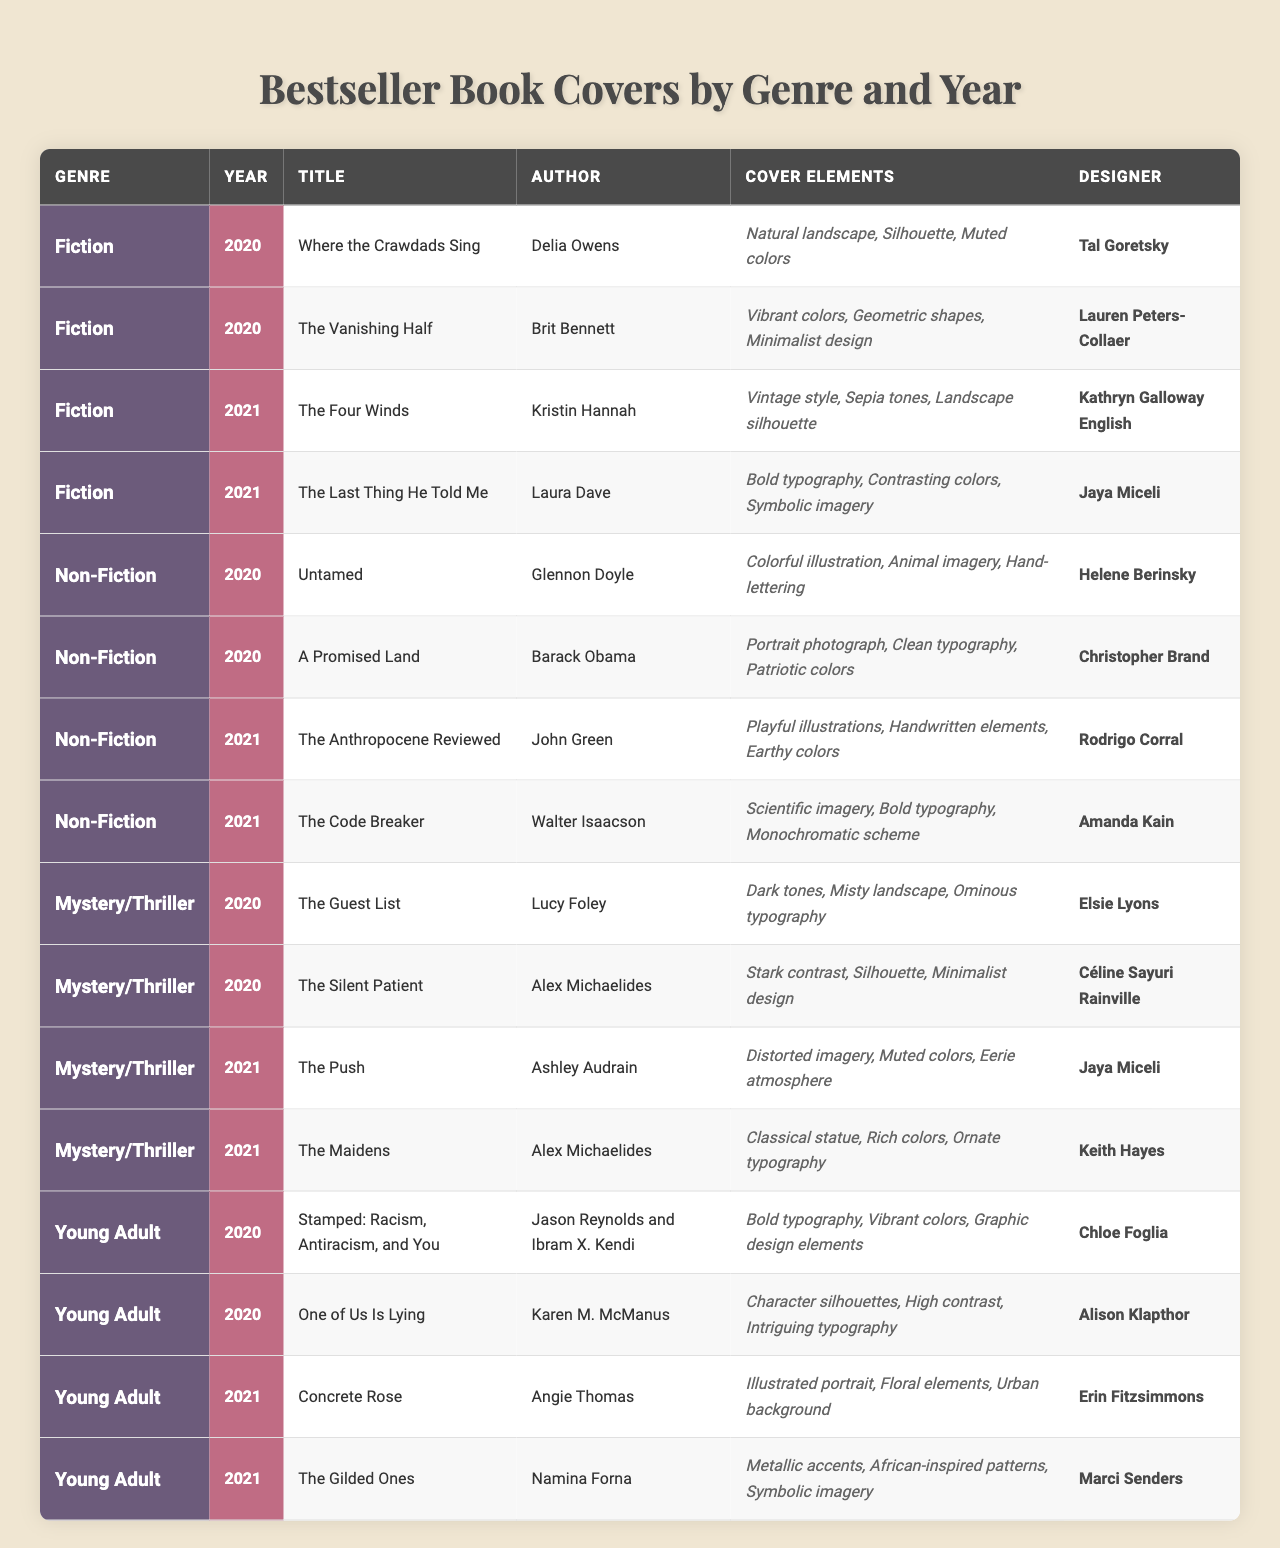What are the cover elements of "The Silent Patient"? According to the table, "The Silent Patient" has the cover elements: Stark contrast, Silhouette, and Minimalist design.
Answer: Stark contrast, Silhouette, Minimalist design Who designed the cover for "Concrete Rose"? The table indicates that "Concrete Rose," written by Angie Thomas, was designed by Erin Fitzsimmons.
Answer: Erin Fitzsimmons How many books from the Fiction genre were published in 2020? There are 2 entries under the Fiction genre for the year 2020, which are "Where the Crawdads Sing" and "The Vanishing Half."
Answer: 2 Is there a book titled "The Code Breaker" in the Non-Fiction genre? Yes, the table confirms that "The Code Breaker" by Walter Isaacson is listed under the Non-Fiction genre for 2021.
Answer: Yes Which designer created the covers for books in both 2020 and 2021 in the Mystery/Thriller genre? Analyzing the table, Jaya Miceli designed "The Push" in 2021 and "The Silent Patient" in 2020. Therefore, only “The Push” (2021) matches this criterion; there’s no overlap in design between both years for Jaya Miceli.
Answer: No What year had the most entries in the Young Adult genre? By reviewing the table, both 2020 and 2021 have 2 entries each in the Young Adult genre; hence, both years are equal in number of books.
Answer: 2020 and 2021 Which book has the most cover elements listed, and how many are there? The book "The Anthropocene Reviewed" has 3 cover elements listed: Playful illustrations, Handwritten elements, and Earthy colors.
Answer: The Anthropocene Reviewed, 3 elements What is the percentage of Non-Fiction books compared to all genres in 2021? There are 2 Non-Fiction books in 2021 and a total of 8 books across all genres. The percentage is calculated as (2 / 8) * 100 = 25%.
Answer: 25% Which genre has the most books in total between 2020 and 2021? By counting the number of books in each genre for both years, Fiction has 4 books, Non-Fiction has 4, Mystery/Thriller has 4, and Young Adult has 4; hence, the genres are equally represented with 4 books each.
Answer: All genres have equal representation, 4 books each How many books designed by Jaya Miceli are in the table? Looking closely at the table, there are 2 books designed by Jaya Miceli: "The Last Thing He Told Me" in 2021 and "The Push" in 2021.
Answer: 2 